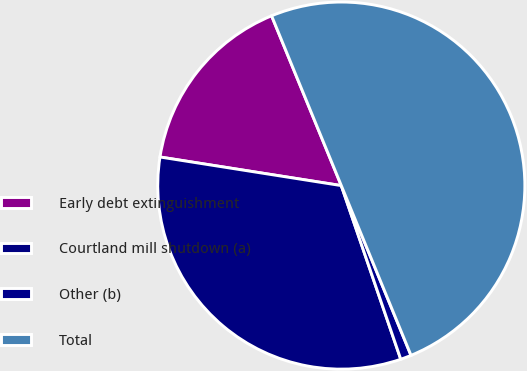Convert chart. <chart><loc_0><loc_0><loc_500><loc_500><pie_chart><fcel>Early debt extinguishment<fcel>Courtland mill shutdown (a)<fcel>Other (b)<fcel>Total<nl><fcel>16.31%<fcel>32.74%<fcel>0.95%<fcel>50.0%<nl></chart> 